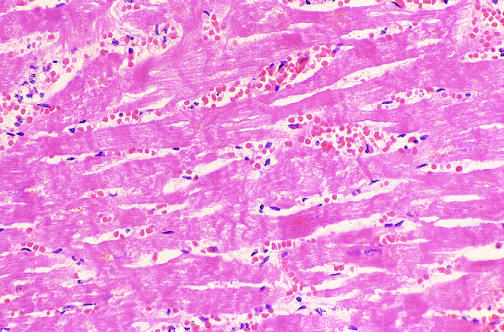re hemorrhage and contraction bands, visible as prominent hypereosinophilic cross-striations spanning myofibers, seen microscopically?
Answer the question using a single word or phrase. Yes 